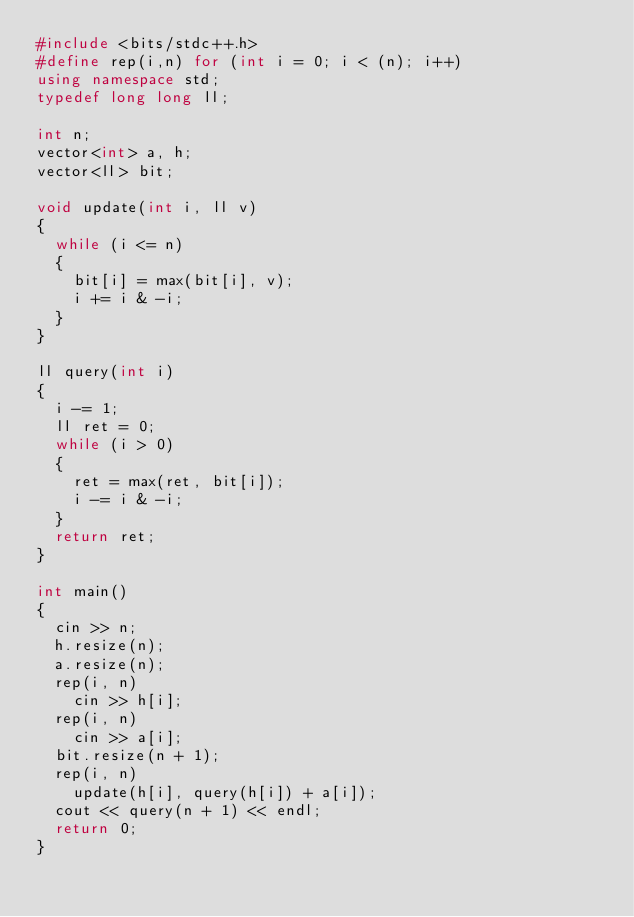<code> <loc_0><loc_0><loc_500><loc_500><_C++_>#include <bits/stdc++.h>
#define rep(i,n) for (int i = 0; i < (n); i++)
using namespace std;
typedef long long ll;

int n;
vector<int> a, h;
vector<ll> bit;

void update(int i, ll v)
{
  while (i <= n)
  {
    bit[i] = max(bit[i], v);
    i += i & -i;
  }
}

ll query(int i)
{
  i -= 1;
  ll ret = 0;
  while (i > 0)
  {
    ret = max(ret, bit[i]);
    i -= i & -i;
  }
  return ret;
}

int main()
{
  cin >> n;
  h.resize(n);
  a.resize(n);
  rep(i, n)
    cin >> h[i];
  rep(i, n)
    cin >> a[i];
  bit.resize(n + 1);
  rep(i, n)
    update(h[i], query(h[i]) + a[i]);
  cout << query(n + 1) << endl;
  return 0;
}</code> 